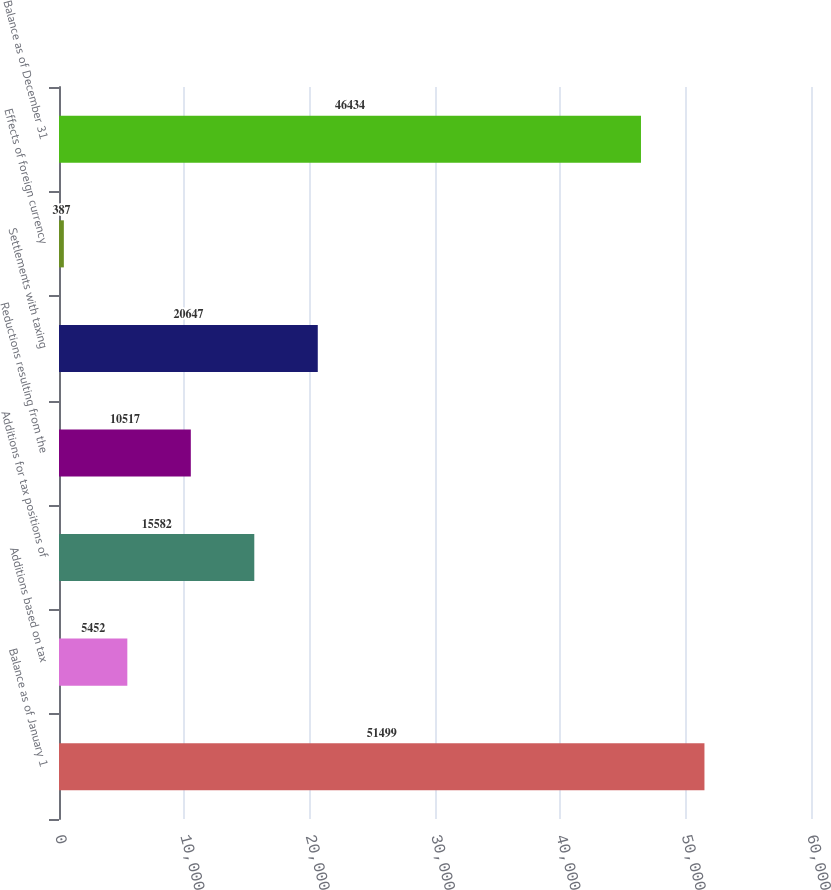<chart> <loc_0><loc_0><loc_500><loc_500><bar_chart><fcel>Balance as of January 1<fcel>Additions based on tax<fcel>Additions for tax positions of<fcel>Reductions resulting from the<fcel>Settlements with taxing<fcel>Effects of foreign currency<fcel>Balance as of December 31<nl><fcel>51499<fcel>5452<fcel>15582<fcel>10517<fcel>20647<fcel>387<fcel>46434<nl></chart> 